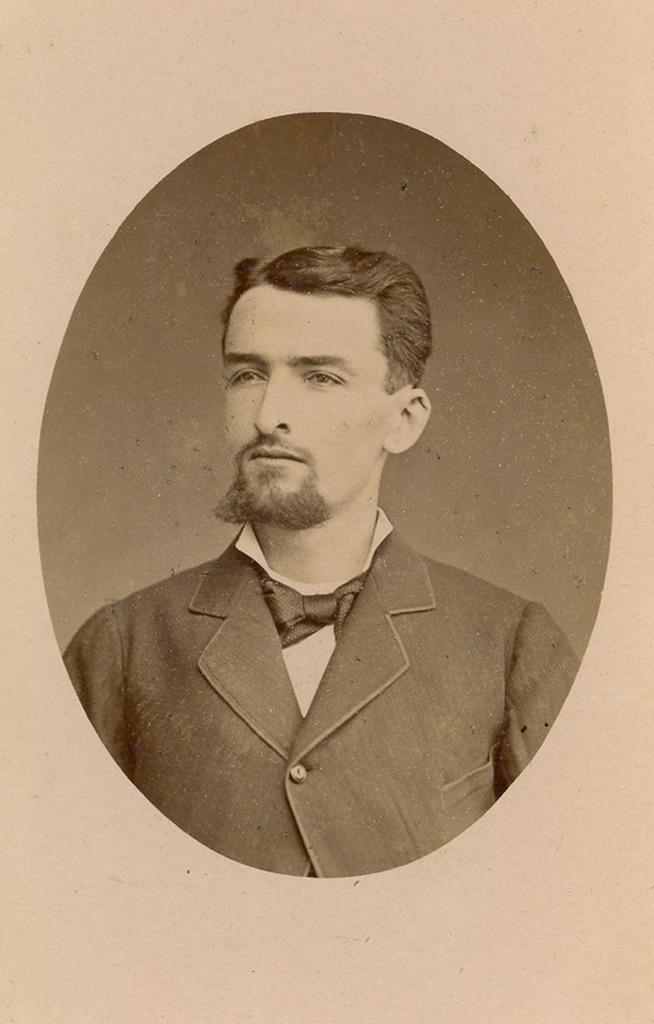What can be said about the nature of the image? The image is edited. Can you describe the main subject of the image? There is a person in the image. What is the person wearing in the image? The person is wearing a suit. What type of jewel is the person holding in the image? There is no jewel present in the image; the person is wearing a suit. What suggestion is the person making in the image? There is no indication of any suggestion being made in the image; the person is simply wearing a suit. 